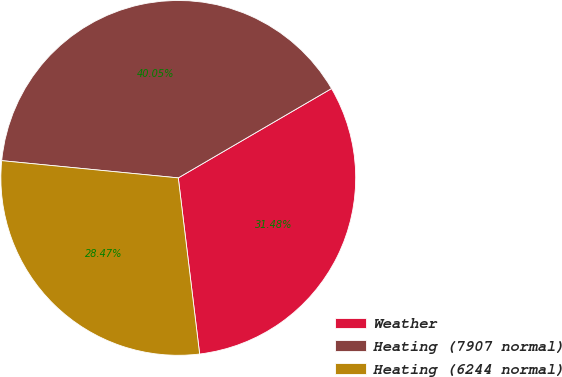Convert chart. <chart><loc_0><loc_0><loc_500><loc_500><pie_chart><fcel>Weather<fcel>Heating (7907 normal)<fcel>Heating (6244 normal)<nl><fcel>31.48%<fcel>40.05%<fcel>28.47%<nl></chart> 